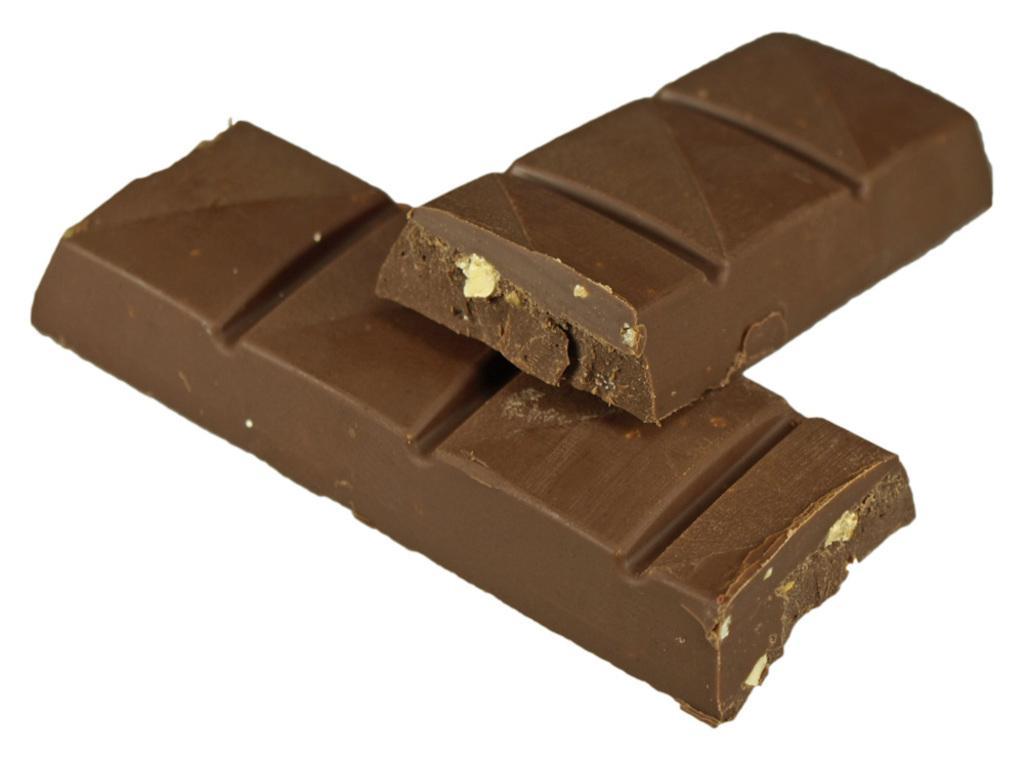How would you summarize this image in a sentence or two? In the image we can see the chocolate bars. 